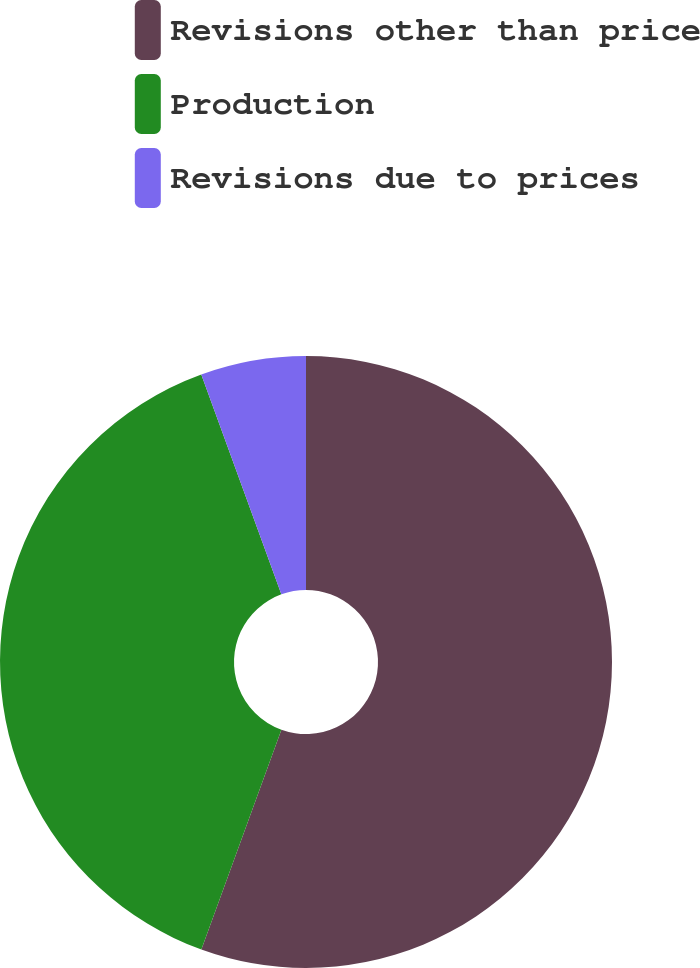Convert chart. <chart><loc_0><loc_0><loc_500><loc_500><pie_chart><fcel>Revisions other than price<fcel>Production<fcel>Revisions due to prices<nl><fcel>55.56%<fcel>38.89%<fcel>5.56%<nl></chart> 